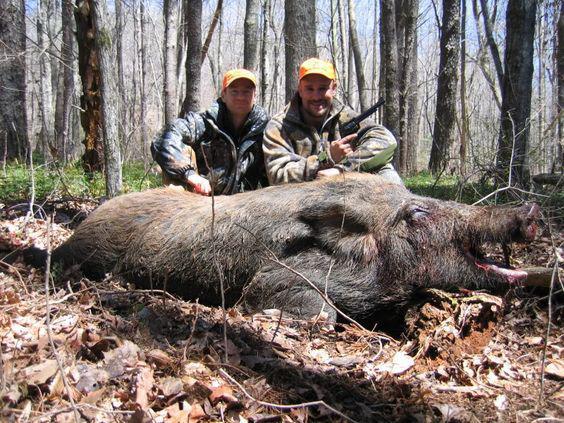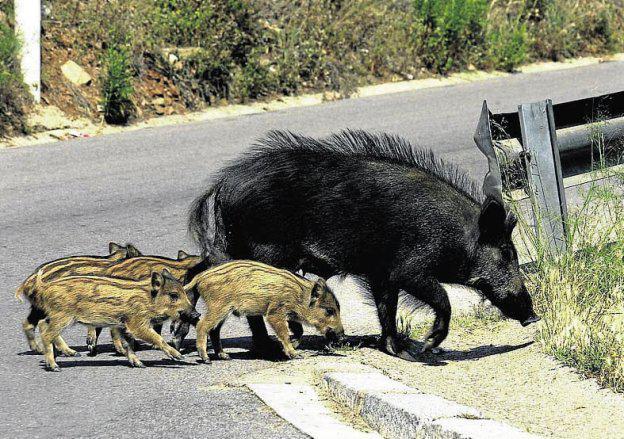The first image is the image on the left, the second image is the image on the right. Given the left and right images, does the statement "There are at least two striped baby hogs standing next to a black adult hog." hold true? Answer yes or no. Yes. The first image is the image on the left, the second image is the image on the right. Analyze the images presented: Is the assertion "The combined images include at least three piglets standing on all fours, and all piglets are near a standing adult pig." valid? Answer yes or no. Yes. 